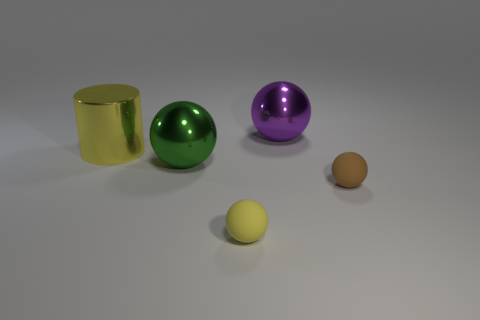Subtract all small brown spheres. How many spheres are left? 3 Add 3 brown balls. How many objects exist? 8 Subtract all brown spheres. How many spheres are left? 3 Subtract all small purple matte balls. Subtract all purple shiny balls. How many objects are left? 4 Add 5 brown rubber balls. How many brown rubber balls are left? 6 Add 1 yellow metallic cylinders. How many yellow metallic cylinders exist? 2 Subtract 1 purple spheres. How many objects are left? 4 Subtract all cylinders. How many objects are left? 4 Subtract 1 cylinders. How many cylinders are left? 0 Subtract all gray balls. Subtract all gray blocks. How many balls are left? 4 